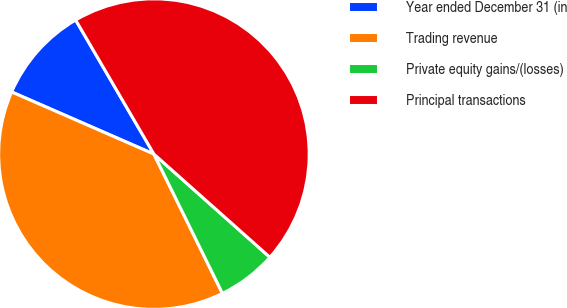<chart> <loc_0><loc_0><loc_500><loc_500><pie_chart><fcel>Year ended December 31 (in<fcel>Trading revenue<fcel>Private equity gains/(losses)<fcel>Principal transactions<nl><fcel>10.04%<fcel>38.83%<fcel>6.15%<fcel>44.98%<nl></chart> 